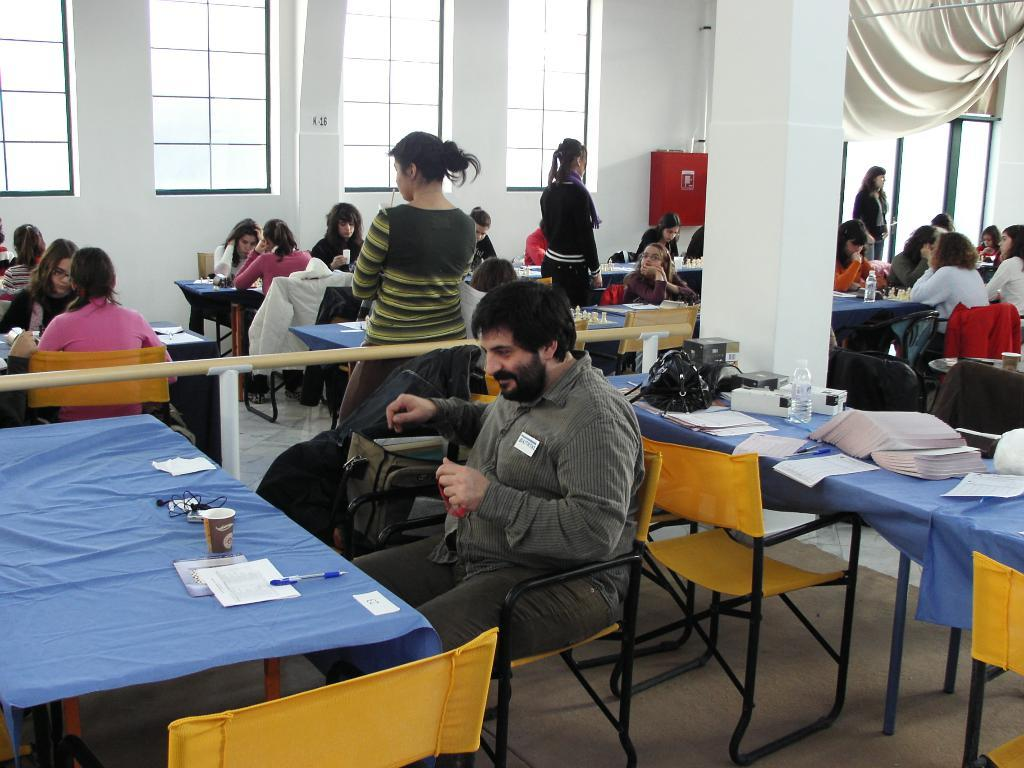What are the people in the image doing? The people in the image are sitting on chairs in front of a table. What might be the purpose of their gathering? It appears to be a competition. What can be seen on the wall in the image? There are windows on the wall. Are there any window treatments present in the image? Yes, there are curtains associated with the windows. What arithmetic problem is being solved on the table in the image? There is no arithmetic problem visible in the image. 